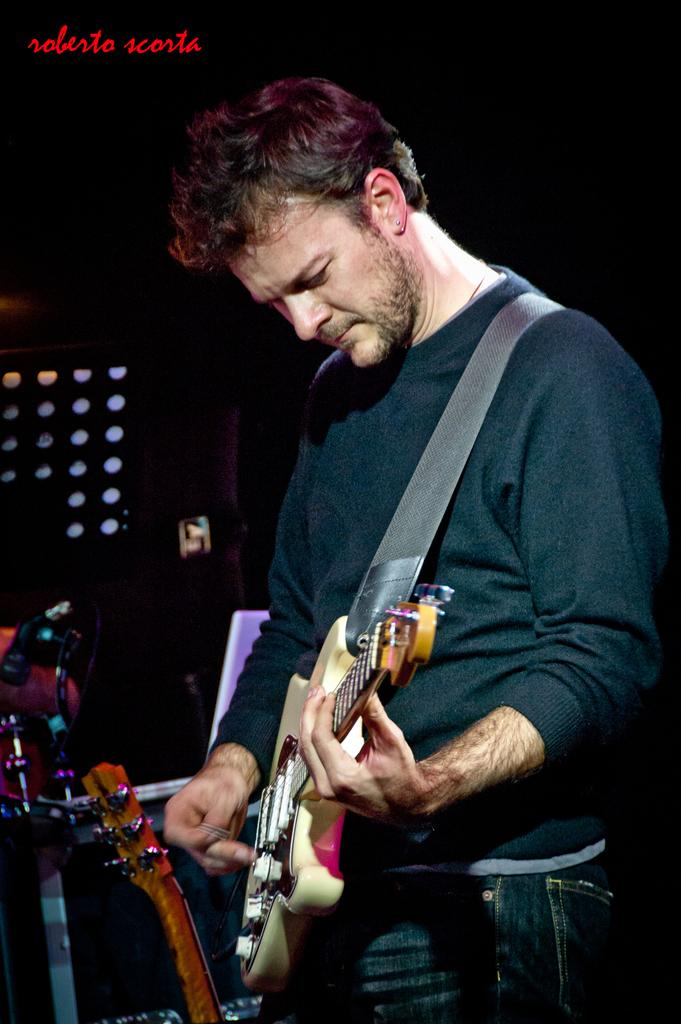What is the man in the image doing? The man is playing a guitar in the image. What other musical instruments are present in the image? There are other musical instruments beside the man. What can be seen in the background of the image? There is a black color wall and lights visible in the background of the image. How many clovers can be seen growing on the wall in the image? There are no clovers visible in the image; the background wall is black. Is there a beggar asking for money in the image? There is no beggar present in the image; the focus is on the man playing the guitar and other musical instruments. 